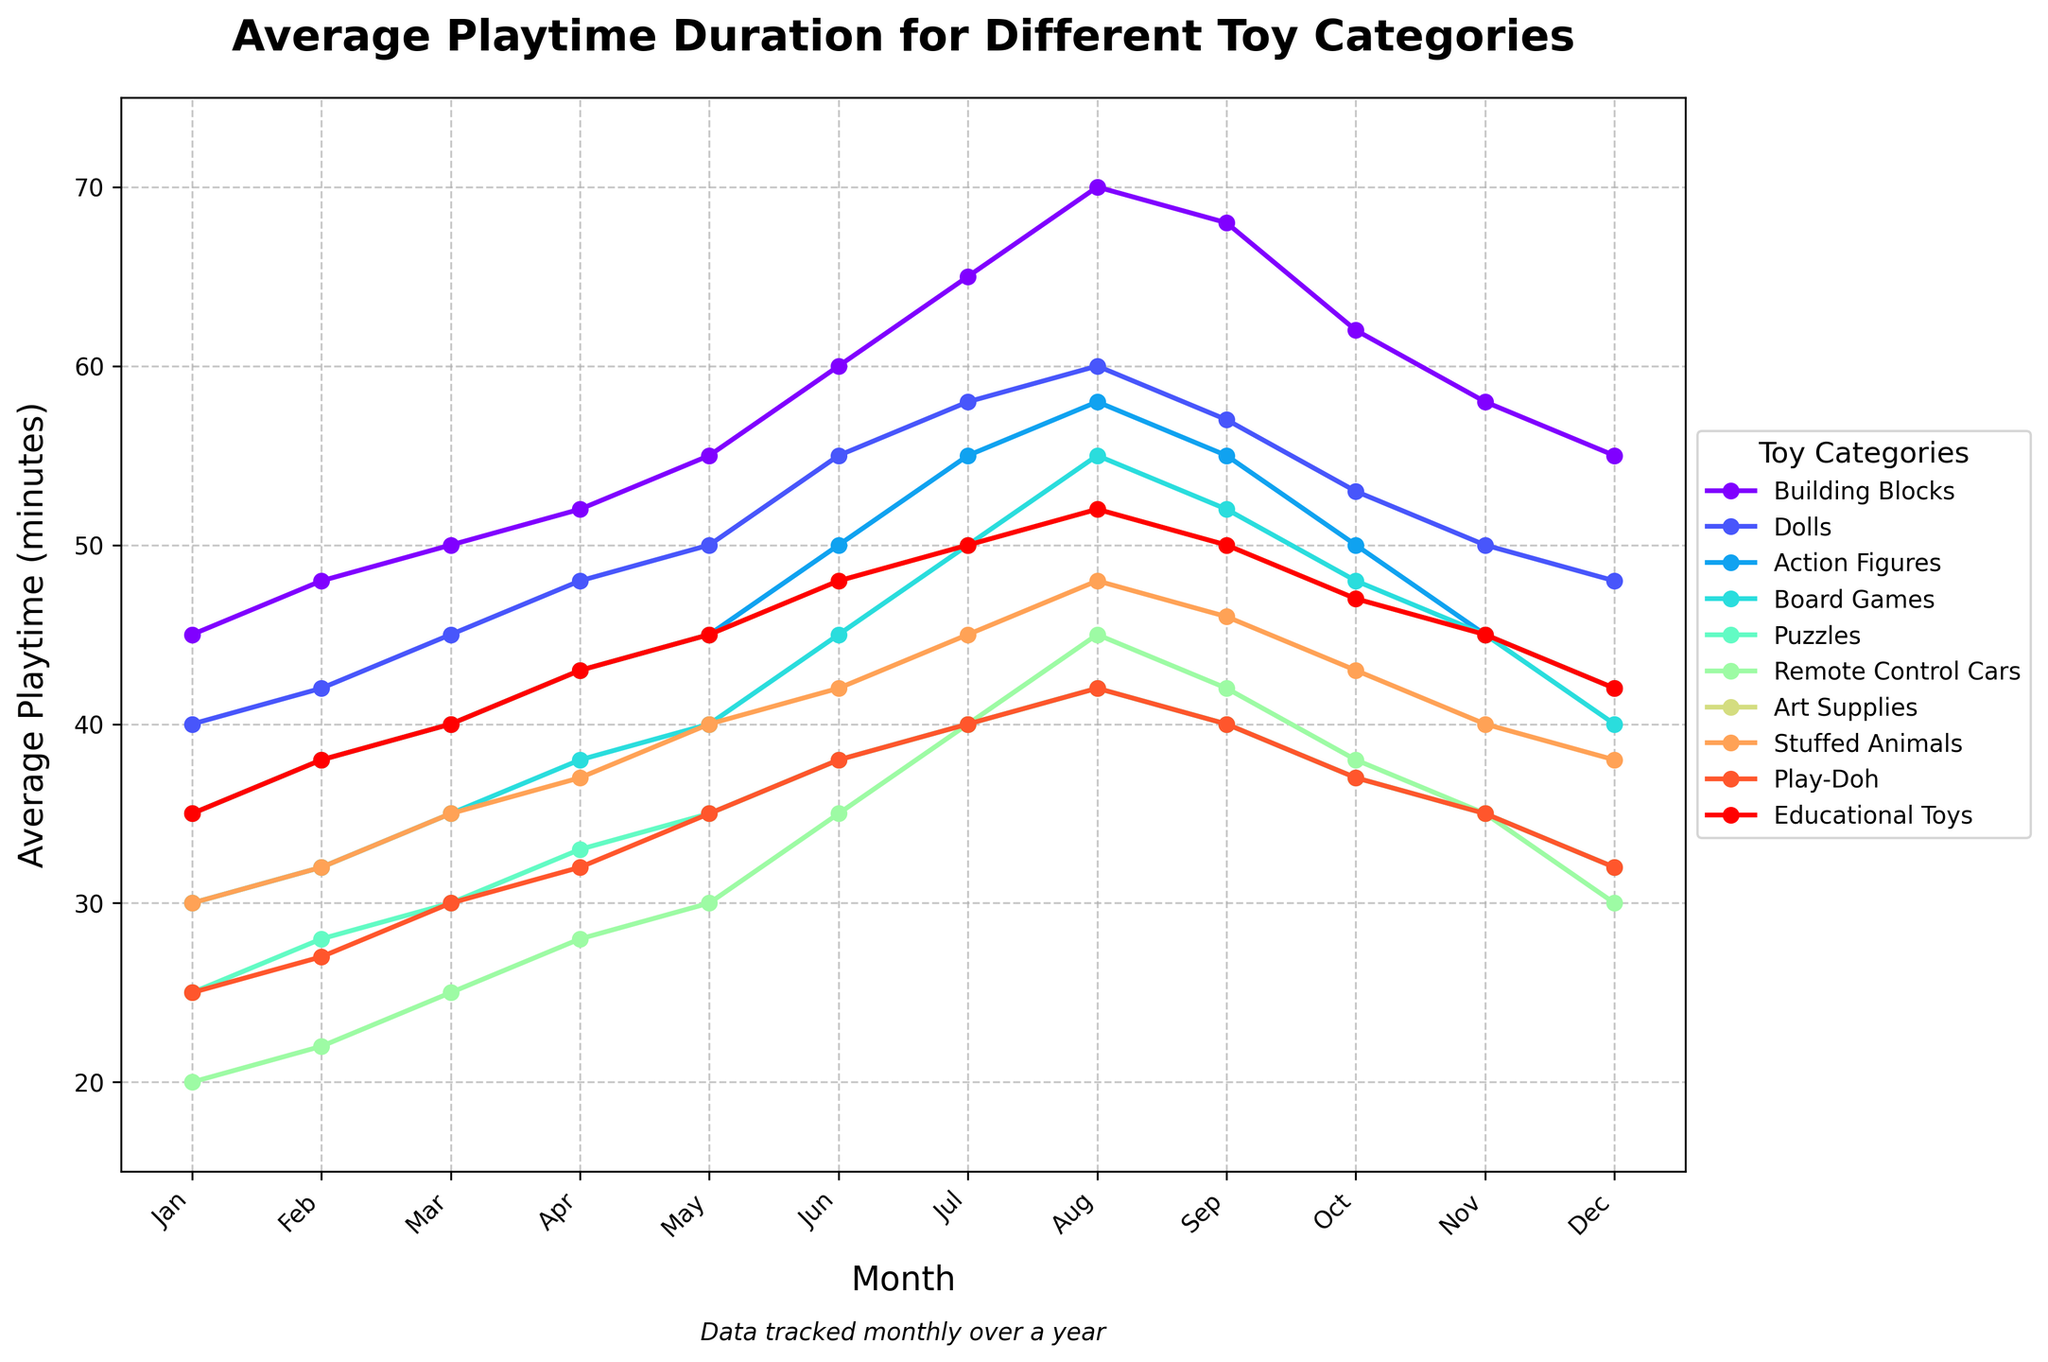What month has the highest average playtime for Building Blocks? To find the month with the highest average playtime for Building Blocks, look at the Building Blocks line in the figure and identify the highest point. The highest playtime is 70 minutes in August.
Answer: August Which toy category had the lowest average playtime in January? Compare the points for each toy category in January and find the lowest value. The lowest average playtime in January is for Remote Control Cars at 20 minutes.
Answer: Remote Control Cars How much did the average playtime for Puzzles increase from January to December? Find the January and December values for Puzzles, then calculate the difference: 32 minutes in December minus 25 minutes in January equals an increase of 7 minutes.
Answer: 7 minutes Which toy category shows the most significant increase in playtime from January to July? Compare the differences between January and July for each toy category. Building Blocks show the largest increase: 65 minutes in July minus 45 minutes in January equals 20 minutes.
Answer: Building Blocks Between September and October, which toy category experienced the smallest decrease in average playtime? Look at the changes between September and October for all toy categories and identify the smallest decrease. Stuffed Animals decreased from 46 to 43, a difference of 3 minutes which is the smallest decrease.
Answer: Stuffed Animals What is the average playtime in June for all toy categories? Sum the playtimes in June for all toy categories and divide by the number of categories. (60 + 55 + 50 + 45 + 38 + 35 + 48 + 42 + 38 + 48) / 10 = 459 / 10 = 45.9 minutes.
Answer: 45.9 minutes In which month did Action Figures have a higher average playtime than Dolls for the first time? Compare the monthly playtimes for Action Figures and Dolls, and identify the first month where Action Figures' playtime exceeds Dolls'. This occurs in July, where Action Figures have 55 minutes, and Dolls have 55 minutes.
Answer: July What is the average playtime for Educational Toys from July to December? Sum the playtimes from July to December for Educational Toys and divide by the number of months. (50 + 52 + 50 + 47 + 45 + 42) / 6 = 286 / 6 = 47.67 minutes.
Answer: 47.67 minutes How does the average playtime for Remote Control Cars in November compare to that in June? Look at the figure to compare the playtimes for Remote Control Cars in November and June. Remote Control Cars had 35 minutes in June and decreased to 30 minutes in November, a difference of 5 minutes.
Answer: Decreased by 5 minutes 